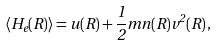Convert formula to latex. <formula><loc_0><loc_0><loc_500><loc_500>\langle H _ { e } ( { R } ) \rangle = u ( { R } ) + \frac { 1 } { 2 } m n ( { R } ) v ^ { 2 } ( { R } ) \, ,</formula> 